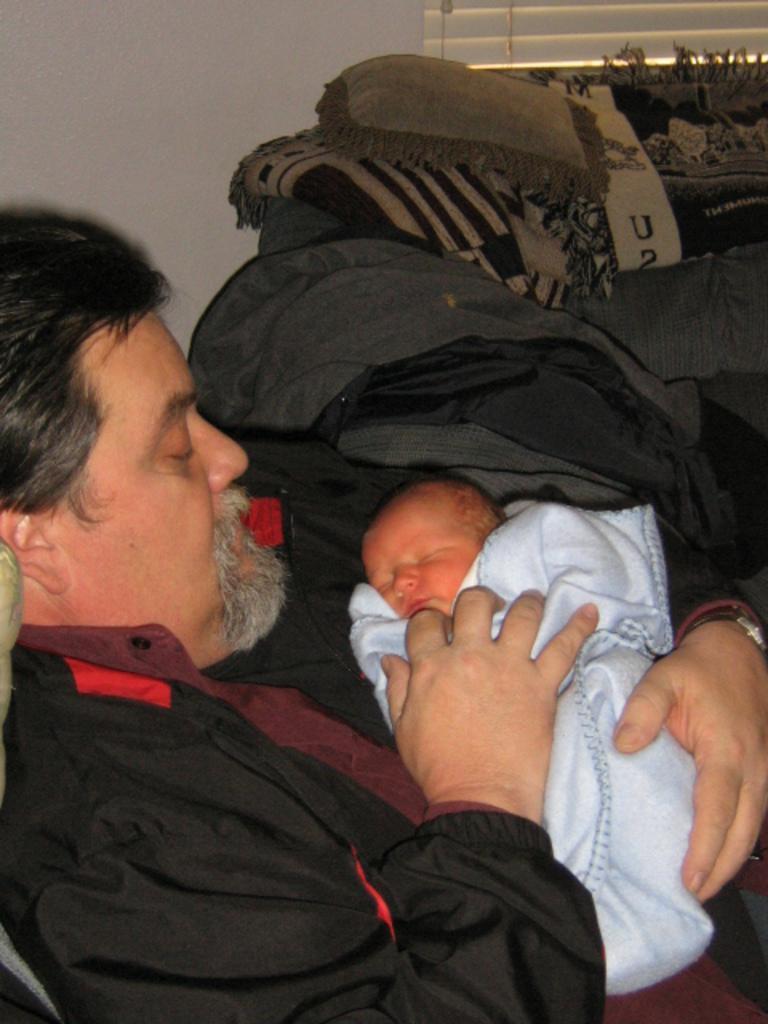Please provide a concise description of this image. In this image I can see a man is holding the baby, he wore black color coat. There is a white color cloth on this baby. 